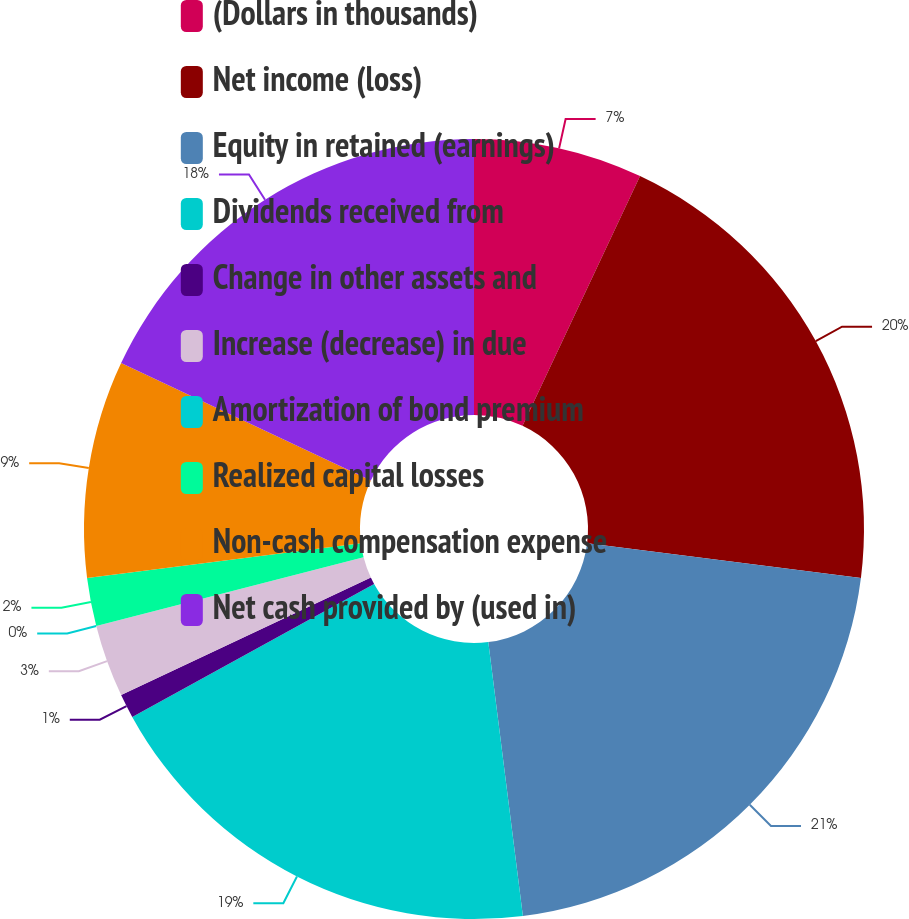Convert chart to OTSL. <chart><loc_0><loc_0><loc_500><loc_500><pie_chart><fcel>(Dollars in thousands)<fcel>Net income (loss)<fcel>Equity in retained (earnings)<fcel>Dividends received from<fcel>Change in other assets and<fcel>Increase (decrease) in due<fcel>Amortization of bond premium<fcel>Realized capital losses<fcel>Non-cash compensation expense<fcel>Net cash provided by (used in)<nl><fcel>7.0%<fcel>20.0%<fcel>21.0%<fcel>19.0%<fcel>1.0%<fcel>3.0%<fcel>0.0%<fcel>2.0%<fcel>9.0%<fcel>18.0%<nl></chart> 